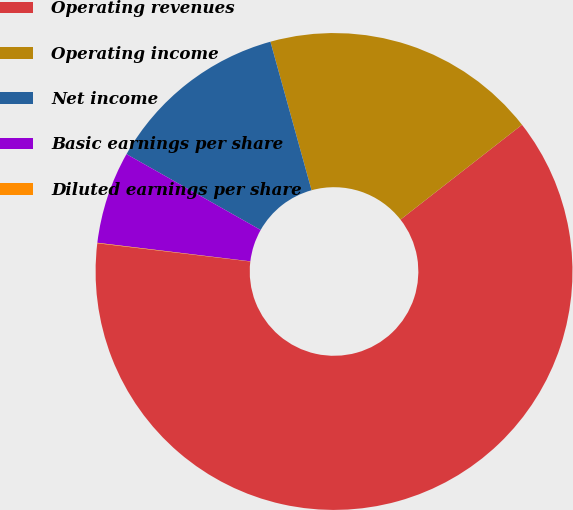Convert chart. <chart><loc_0><loc_0><loc_500><loc_500><pie_chart><fcel>Operating revenues<fcel>Operating income<fcel>Net income<fcel>Basic earnings per share<fcel>Diluted earnings per share<nl><fcel>62.44%<fcel>18.75%<fcel>12.51%<fcel>6.27%<fcel>0.03%<nl></chart> 